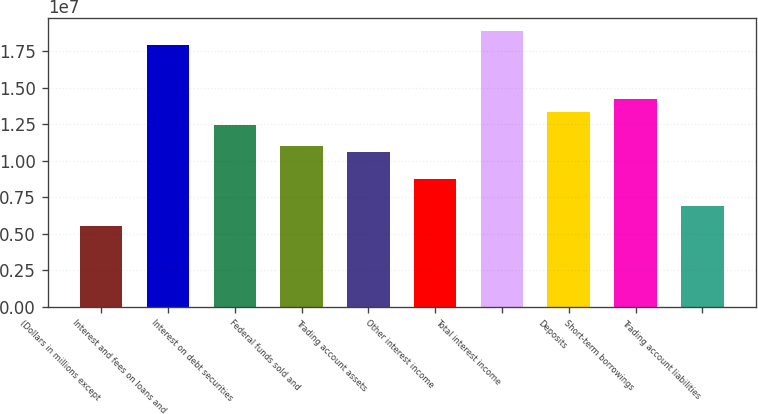<chart> <loc_0><loc_0><loc_500><loc_500><bar_chart><fcel>(Dollars in millions except<fcel>Interest and fees on loans and<fcel>Interest on debt securities<fcel>Federal funds sold and<fcel>Trading account assets<fcel>Other interest income<fcel>Total interest income<fcel>Deposits<fcel>Short-term borrowings<fcel>Trading account liabilities<nl><fcel>5.51507e+06<fcel>1.7924e+07<fcel>1.24089e+07<fcel>1.10301e+07<fcel>1.05706e+07<fcel>8.7322e+06<fcel>1.88432e+07<fcel>1.33281e+07<fcel>1.42473e+07<fcel>6.89384e+06<nl></chart> 